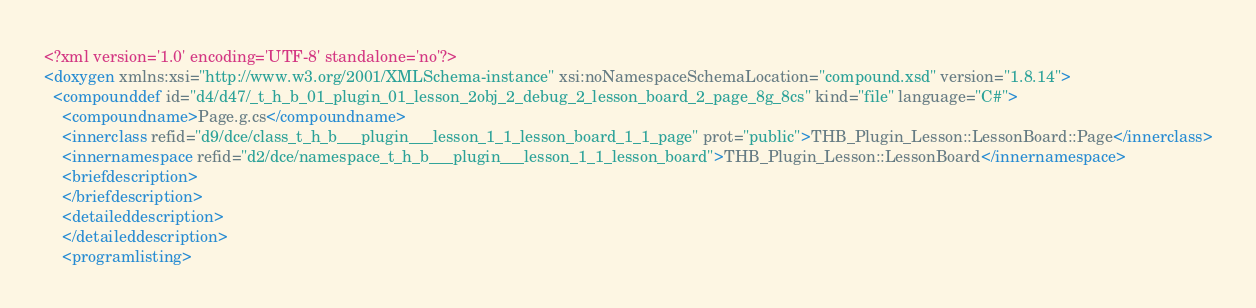Convert code to text. <code><loc_0><loc_0><loc_500><loc_500><_XML_><?xml version='1.0' encoding='UTF-8' standalone='no'?>
<doxygen xmlns:xsi="http://www.w3.org/2001/XMLSchema-instance" xsi:noNamespaceSchemaLocation="compound.xsd" version="1.8.14">
  <compounddef id="d4/d47/_t_h_b_01_plugin_01_lesson_2obj_2_debug_2_lesson_board_2_page_8g_8cs" kind="file" language="C#">
    <compoundname>Page.g.cs</compoundname>
    <innerclass refid="d9/dce/class_t_h_b___plugin___lesson_1_1_lesson_board_1_1_page" prot="public">THB_Plugin_Lesson::LessonBoard::Page</innerclass>
    <innernamespace refid="d2/dce/namespace_t_h_b___plugin___lesson_1_1_lesson_board">THB_Plugin_Lesson::LessonBoard</innernamespace>
    <briefdescription>
    </briefdescription>
    <detaileddescription>
    </detaileddescription>
    <programlisting></code> 